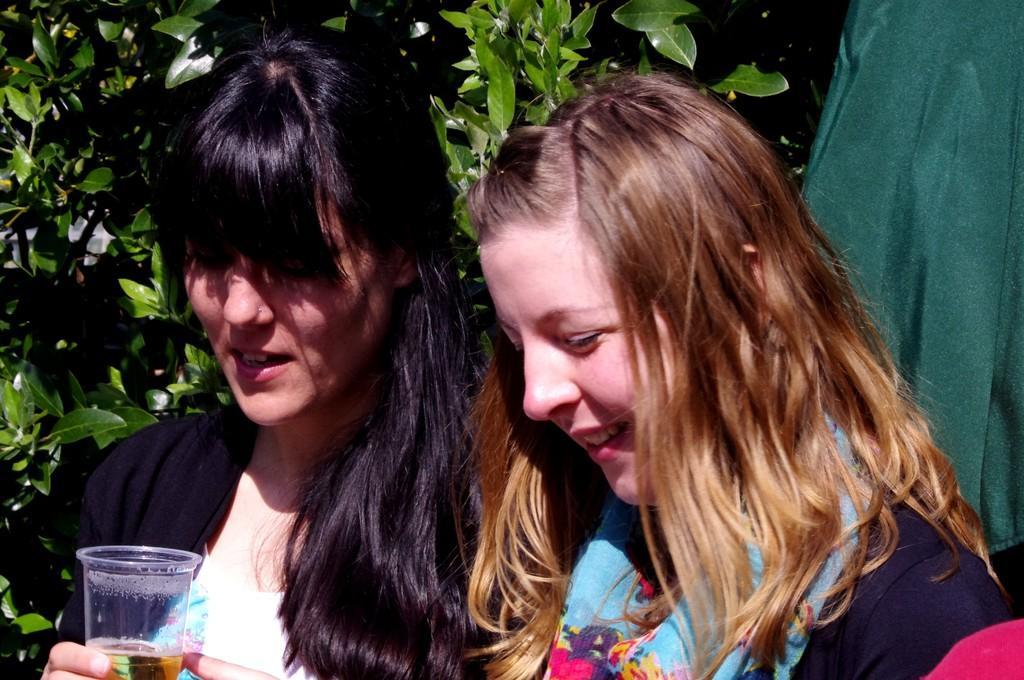Can you describe this image briefly? In this picture we can observe two women. One of them is holding a glass in her hands and the other is smiling. In the background there are trees. 